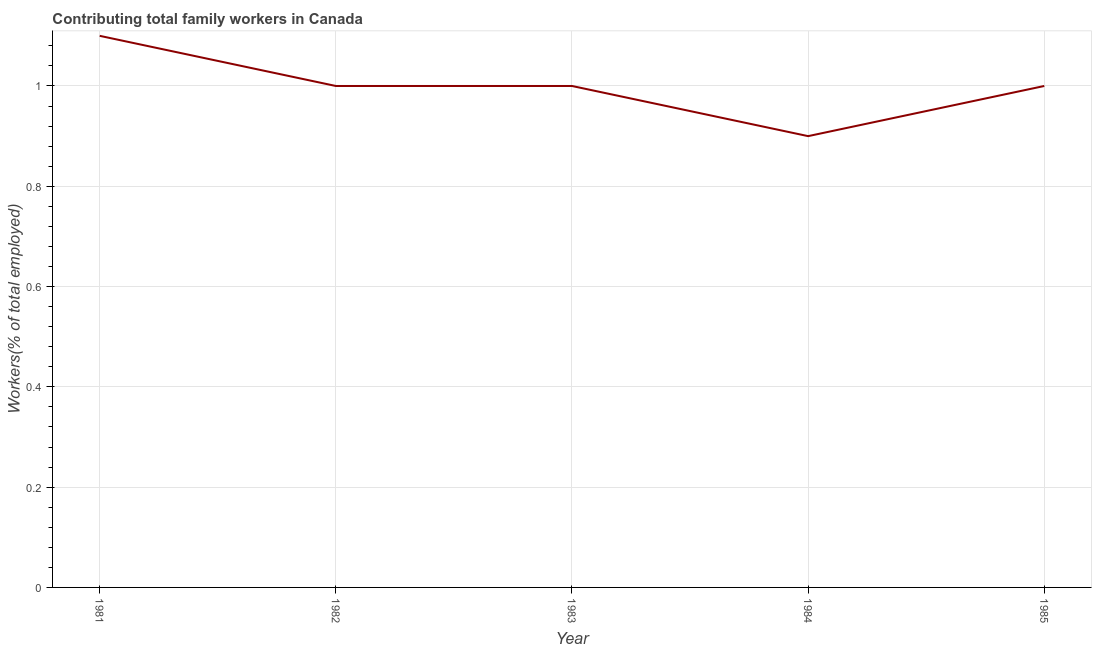What is the contributing family workers in 1982?
Your response must be concise. 1. Across all years, what is the maximum contributing family workers?
Your answer should be very brief. 1.1. Across all years, what is the minimum contributing family workers?
Make the answer very short. 0.9. What is the sum of the contributing family workers?
Your answer should be compact. 5. What is the difference between the contributing family workers in 1981 and 1982?
Make the answer very short. 0.1. What is the average contributing family workers per year?
Your answer should be compact. 1. What is the median contributing family workers?
Provide a short and direct response. 1. Do a majority of the years between 1985 and 1984 (inclusive) have contributing family workers greater than 0.9600000000000001 %?
Provide a succinct answer. No. What is the difference between the highest and the second highest contributing family workers?
Provide a succinct answer. 0.1. Is the sum of the contributing family workers in 1983 and 1984 greater than the maximum contributing family workers across all years?
Give a very brief answer. Yes. What is the difference between the highest and the lowest contributing family workers?
Your response must be concise. 0.2. Does the contributing family workers monotonically increase over the years?
Your answer should be very brief. No. How many lines are there?
Your answer should be compact. 1. How many years are there in the graph?
Provide a short and direct response. 5. Are the values on the major ticks of Y-axis written in scientific E-notation?
Your answer should be compact. No. Does the graph contain grids?
Offer a terse response. Yes. What is the title of the graph?
Keep it short and to the point. Contributing total family workers in Canada. What is the label or title of the X-axis?
Your response must be concise. Year. What is the label or title of the Y-axis?
Offer a terse response. Workers(% of total employed). What is the Workers(% of total employed) of 1981?
Your answer should be compact. 1.1. What is the Workers(% of total employed) of 1982?
Ensure brevity in your answer.  1. What is the Workers(% of total employed) of 1983?
Your answer should be very brief. 1. What is the Workers(% of total employed) in 1984?
Your response must be concise. 0.9. What is the difference between the Workers(% of total employed) in 1981 and 1982?
Ensure brevity in your answer.  0.1. What is the difference between the Workers(% of total employed) in 1981 and 1984?
Make the answer very short. 0.2. What is the difference between the Workers(% of total employed) in 1981 and 1985?
Your answer should be compact. 0.1. What is the difference between the Workers(% of total employed) in 1983 and 1984?
Keep it short and to the point. 0.1. What is the difference between the Workers(% of total employed) in 1983 and 1985?
Provide a short and direct response. 0. What is the difference between the Workers(% of total employed) in 1984 and 1985?
Offer a very short reply. -0.1. What is the ratio of the Workers(% of total employed) in 1981 to that in 1982?
Make the answer very short. 1.1. What is the ratio of the Workers(% of total employed) in 1981 to that in 1983?
Your answer should be very brief. 1.1. What is the ratio of the Workers(% of total employed) in 1981 to that in 1984?
Offer a very short reply. 1.22. What is the ratio of the Workers(% of total employed) in 1982 to that in 1984?
Ensure brevity in your answer.  1.11. What is the ratio of the Workers(% of total employed) in 1982 to that in 1985?
Keep it short and to the point. 1. What is the ratio of the Workers(% of total employed) in 1983 to that in 1984?
Make the answer very short. 1.11. What is the ratio of the Workers(% of total employed) in 1983 to that in 1985?
Ensure brevity in your answer.  1. What is the ratio of the Workers(% of total employed) in 1984 to that in 1985?
Offer a terse response. 0.9. 